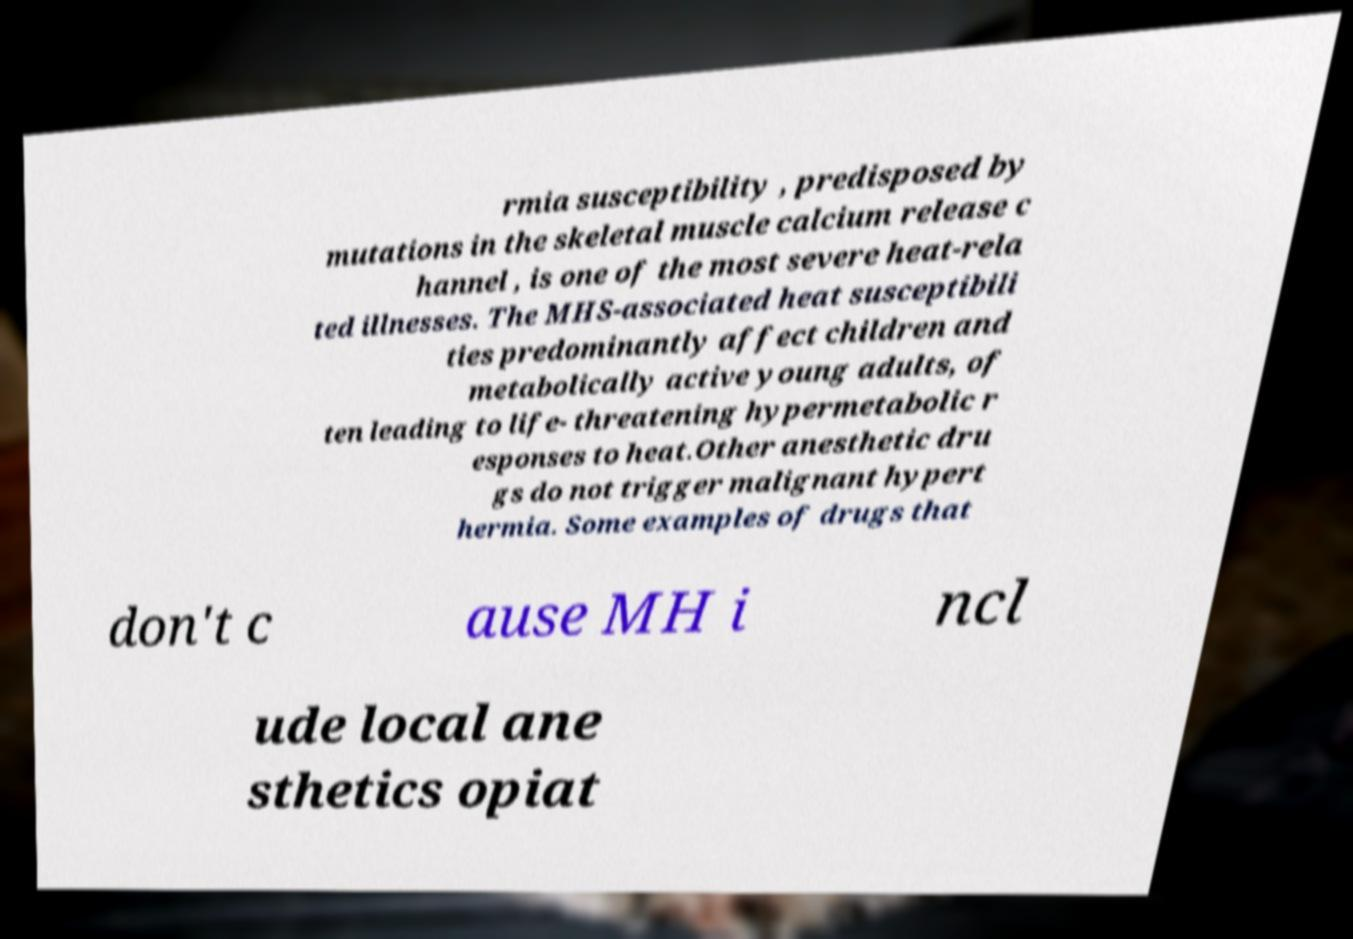I need the written content from this picture converted into text. Can you do that? rmia susceptibility , predisposed by mutations in the skeletal muscle calcium release c hannel , is one of the most severe heat-rela ted illnesses. The MHS-associated heat susceptibili ties predominantly affect children and metabolically active young adults, of ten leading to life- threatening hypermetabolic r esponses to heat.Other anesthetic dru gs do not trigger malignant hypert hermia. Some examples of drugs that don't c ause MH i ncl ude local ane sthetics opiat 